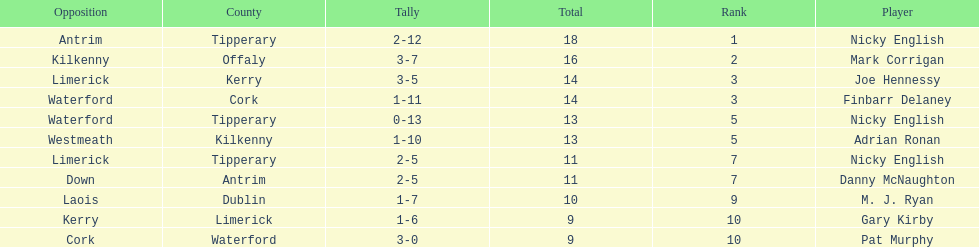How many times was waterford the opposition? 2. 